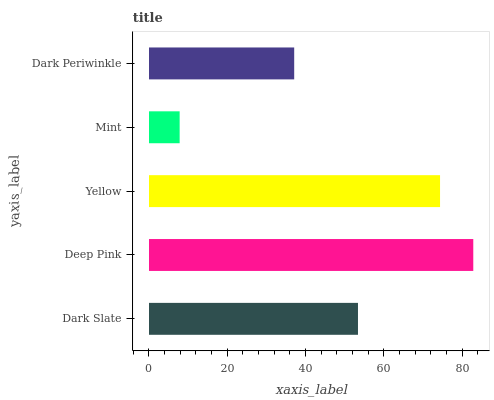Is Mint the minimum?
Answer yes or no. Yes. Is Deep Pink the maximum?
Answer yes or no. Yes. Is Yellow the minimum?
Answer yes or no. No. Is Yellow the maximum?
Answer yes or no. No. Is Deep Pink greater than Yellow?
Answer yes or no. Yes. Is Yellow less than Deep Pink?
Answer yes or no. Yes. Is Yellow greater than Deep Pink?
Answer yes or no. No. Is Deep Pink less than Yellow?
Answer yes or no. No. Is Dark Slate the high median?
Answer yes or no. Yes. Is Dark Slate the low median?
Answer yes or no. Yes. Is Yellow the high median?
Answer yes or no. No. Is Yellow the low median?
Answer yes or no. No. 